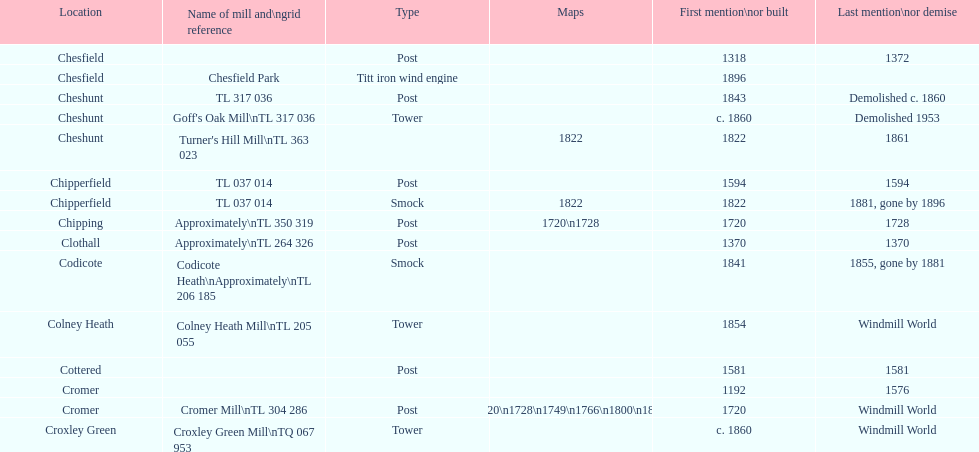Would you mind parsing the complete table? {'header': ['Location', 'Name of mill and\\ngrid reference', 'Type', 'Maps', 'First mention\\nor built', 'Last mention\\nor demise'], 'rows': [['Chesfield', '', 'Post', '', '1318', '1372'], ['Chesfield', 'Chesfield Park', 'Titt iron wind engine', '', '1896', ''], ['Cheshunt', 'TL 317 036', 'Post', '', '1843', 'Demolished c. 1860'], ['Cheshunt', "Goff's Oak Mill\\nTL 317 036", 'Tower', '', 'c. 1860', 'Demolished 1953'], ['Cheshunt', "Turner's Hill Mill\\nTL 363 023", '', '1822', '1822', '1861'], ['Chipperfield', 'TL 037 014', 'Post', '', '1594', '1594'], ['Chipperfield', 'TL 037 014', 'Smock', '1822', '1822', '1881, gone by 1896'], ['Chipping', 'Approximately\\nTL 350 319', 'Post', '1720\\n1728', '1720', '1728'], ['Clothall', 'Approximately\\nTL 264 326', 'Post', '', '1370', '1370'], ['Codicote', 'Codicote Heath\\nApproximately\\nTL 206 185', 'Smock', '', '1841', '1855, gone by 1881'], ['Colney Heath', 'Colney Heath Mill\\nTL 205 055', 'Tower', '', '1854', 'Windmill World'], ['Cottered', '', 'Post', '', '1581', '1581'], ['Cromer', '', '', '', '1192', '1576'], ['Cromer', 'Cromer Mill\\nTL 304 286', 'Post', '1720\\n1728\\n1749\\n1766\\n1800\\n1822', '1720', 'Windmill World'], ['Croxley Green', 'Croxley Green Mill\\nTQ 067 953', 'Tower', '', 'c. 1860', 'Windmill World']]} How many mills were built or first mentioned after 1800? 8. 